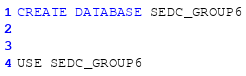Convert code to text. <code><loc_0><loc_0><loc_500><loc_500><_SQL_>CREATE DATABASE SEDC_GROUP6


USE SEDC_GROUP6</code> 